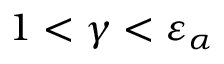<formula> <loc_0><loc_0><loc_500><loc_500>1 < \gamma < \varepsilon _ { \alpha }</formula> 